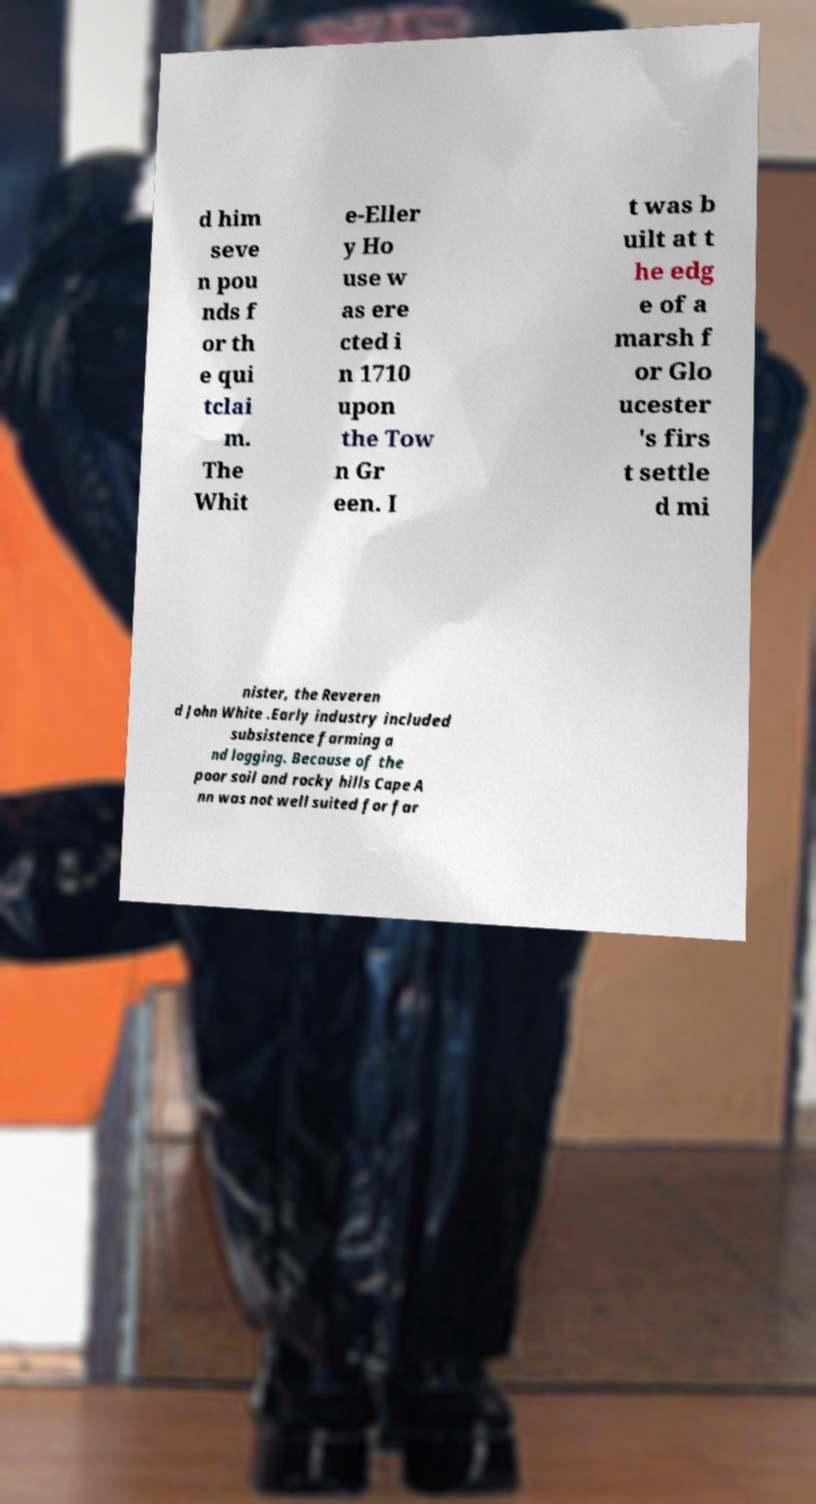Could you assist in decoding the text presented in this image and type it out clearly? d him seve n pou nds f or th e qui tclai m. The Whit e-Eller y Ho use w as ere cted i n 1710 upon the Tow n Gr een. I t was b uilt at t he edg e of a marsh f or Glo ucester 's firs t settle d mi nister, the Reveren d John White .Early industry included subsistence farming a nd logging. Because of the poor soil and rocky hills Cape A nn was not well suited for far 